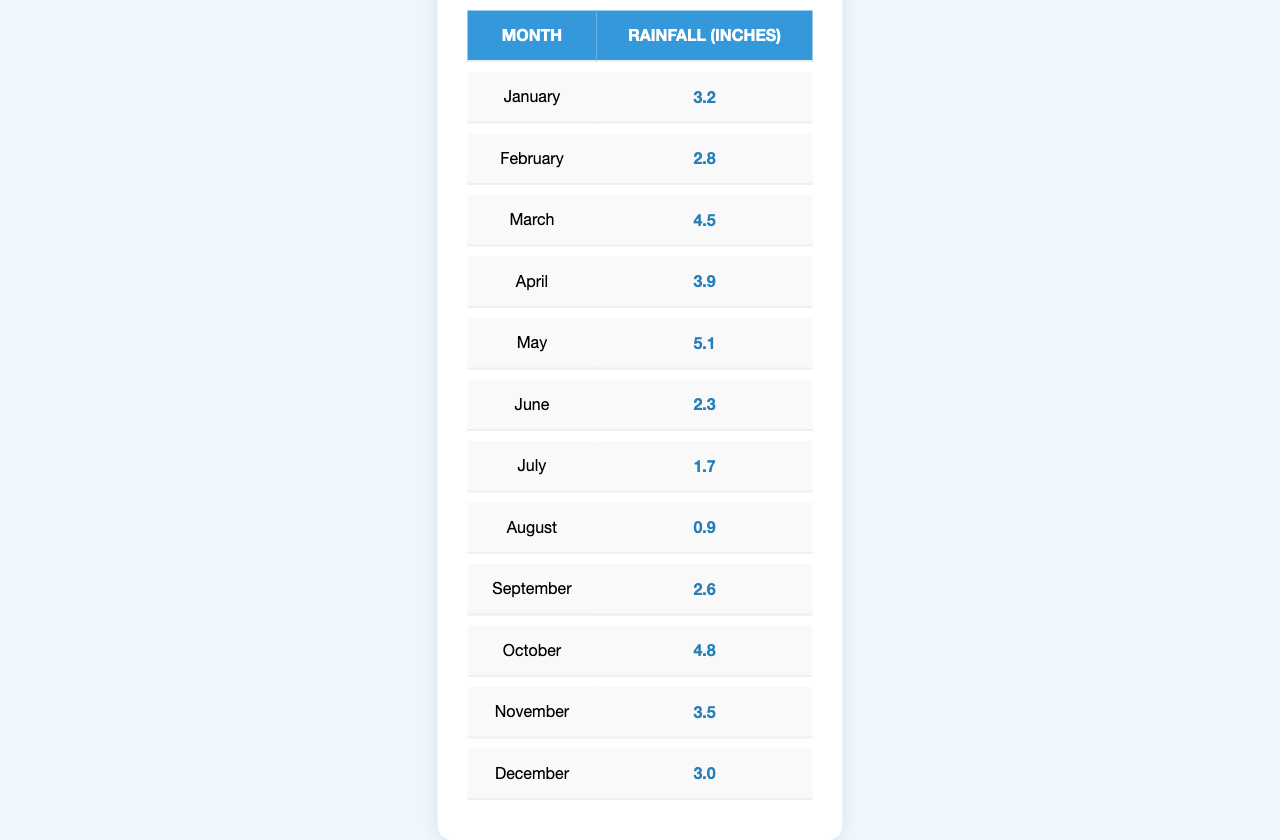What was the total rainfall in May? From the table, the rainfall total for May is directly listed as 5.1 inches.
Answer: 5.1 Which month had the highest rainfall? By comparing the rainfall totals, July had the lowest at 1.7 inches, and May had the highest total of 5.1 inches.
Answer: May What is the average monthly rainfall for the year? First, we add the total rainfall values: (3.2 + 2.8 + 4.5 + 3.9 + 5.1 + 2.3 + 1.7 + 0.9 + 2.6 + 4.8 + 3.5 + 3.0) = 34.1 inches. We then divide this by 12 months, resulting in approximately 2.84 inches per month.
Answer: 2.84 Was there more rainfall in the first half of the year compared to the second half? The total rainfall from January to June is 3.2 + 2.8 + 4.5 + 3.9 + 5.1 + 2.3 = 21.8 inches. From July to December, it is 1.7 + 0.9 + 2.6 + 4.8 + 3.5 + 3.0 = 16.5 inches. Since 21.8 inches is greater than 16.5 inches, it confirms more rainfall in the first half.
Answer: Yes How much more rainfall was there in April compared to August? April had 3.9 inches of rainfall, while August had only 0.9 inches. The difference is 3.9 - 0.9 = 3.0 inches.
Answer: 3.0 Is the total rainfall in the last three months (October to December) greater than in January? The total for October to December is 4.8 + 3.5 + 3.0 = 11.3 inches, while January's total is 3.2 inches. 11.3 inches is greater than 3.2 inches.
Answer: Yes What is the median rainfall from the monthly totals? To find the median, we first list the monthly totals in order: 0.9, 1.7, 2.3, 2.6, 2.8, 3.0, 3.2, 3.5, 3.9, 4.5, 4.8, 5.1. With 12 data points, the median is calculated by taking the average of the 6th and 7th values: (3.0 + 3.2) / 2 = 3.1 inches.
Answer: 3.1 Which month had less than 3 inches of rainfall? By checking the monthly totals, we can see that July (1.7 inches) and August (0.9 inches) both had less than 3 inches of rainfall.
Answer: July and August 